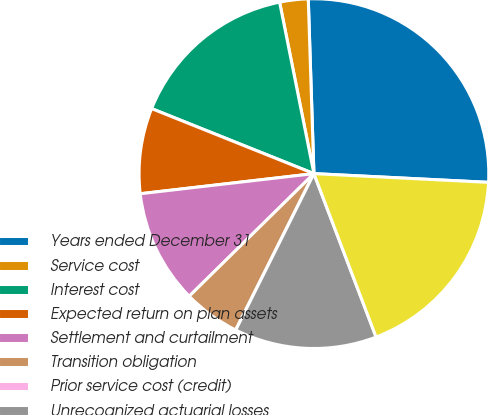Convert chart. <chart><loc_0><loc_0><loc_500><loc_500><pie_chart><fcel>Years ended December 31<fcel>Service cost<fcel>Interest cost<fcel>Expected return on plan assets<fcel>Settlement and curtailment<fcel>Transition obligation<fcel>Prior service cost (credit)<fcel>Unrecognized actuarial losses<fcel>Net periodic cost<nl><fcel>26.31%<fcel>2.63%<fcel>15.79%<fcel>7.9%<fcel>10.53%<fcel>5.26%<fcel>0.0%<fcel>13.16%<fcel>18.42%<nl></chart> 